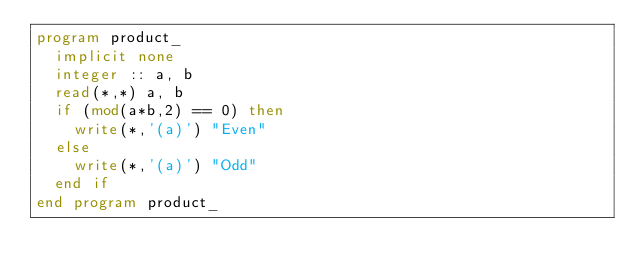Convert code to text. <code><loc_0><loc_0><loc_500><loc_500><_FORTRAN_>program product_
  implicit none
  integer :: a, b
  read(*,*) a, b
  if (mod(a*b,2) == 0) then
    write(*,'(a)') "Even"
  else
    write(*,'(a)') "Odd"
  end if
end program product_</code> 